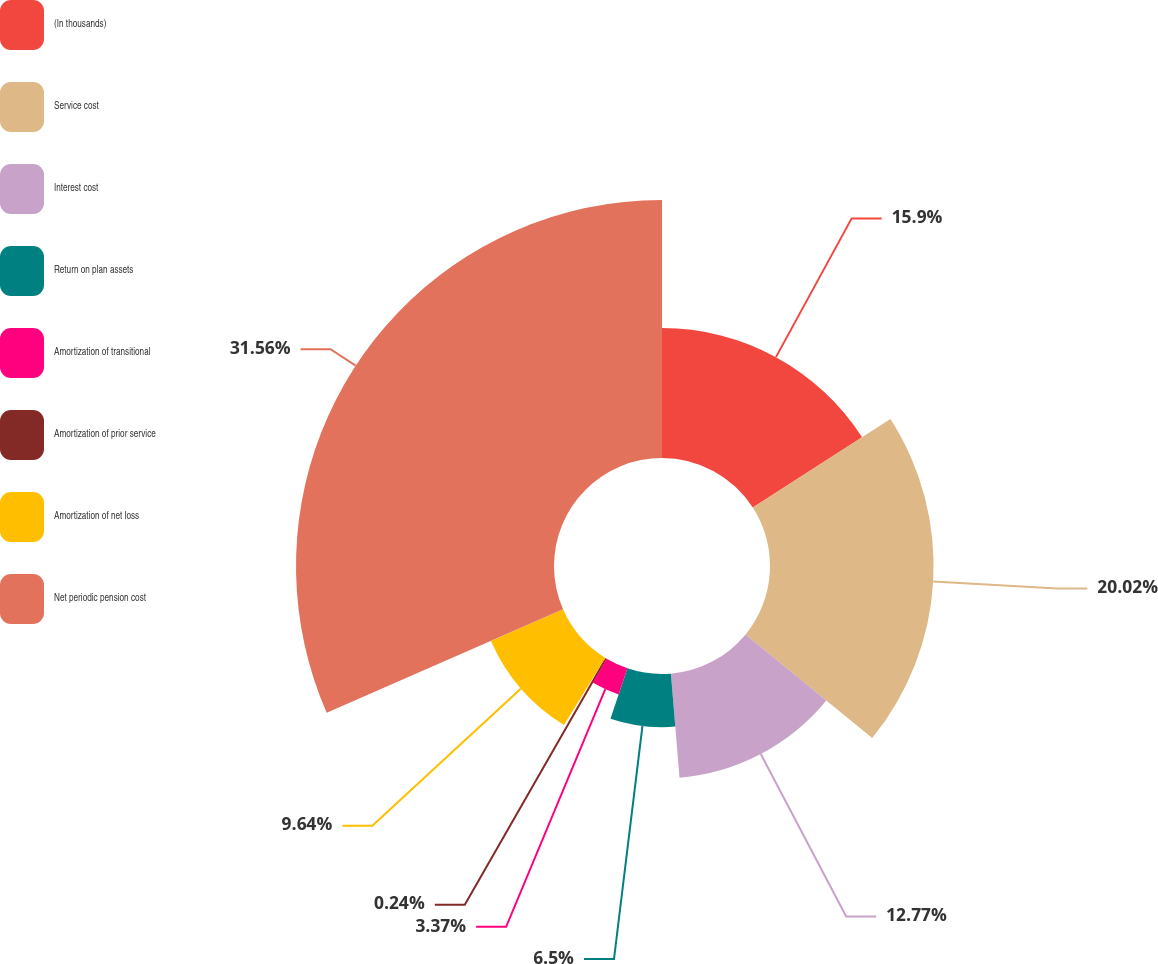<chart> <loc_0><loc_0><loc_500><loc_500><pie_chart><fcel>(In thousands)<fcel>Service cost<fcel>Interest cost<fcel>Return on plan assets<fcel>Amortization of transitional<fcel>Amortization of prior service<fcel>Amortization of net loss<fcel>Net periodic pension cost<nl><fcel>15.9%<fcel>20.02%<fcel>12.77%<fcel>6.5%<fcel>3.37%<fcel>0.24%<fcel>9.64%<fcel>31.57%<nl></chart> 